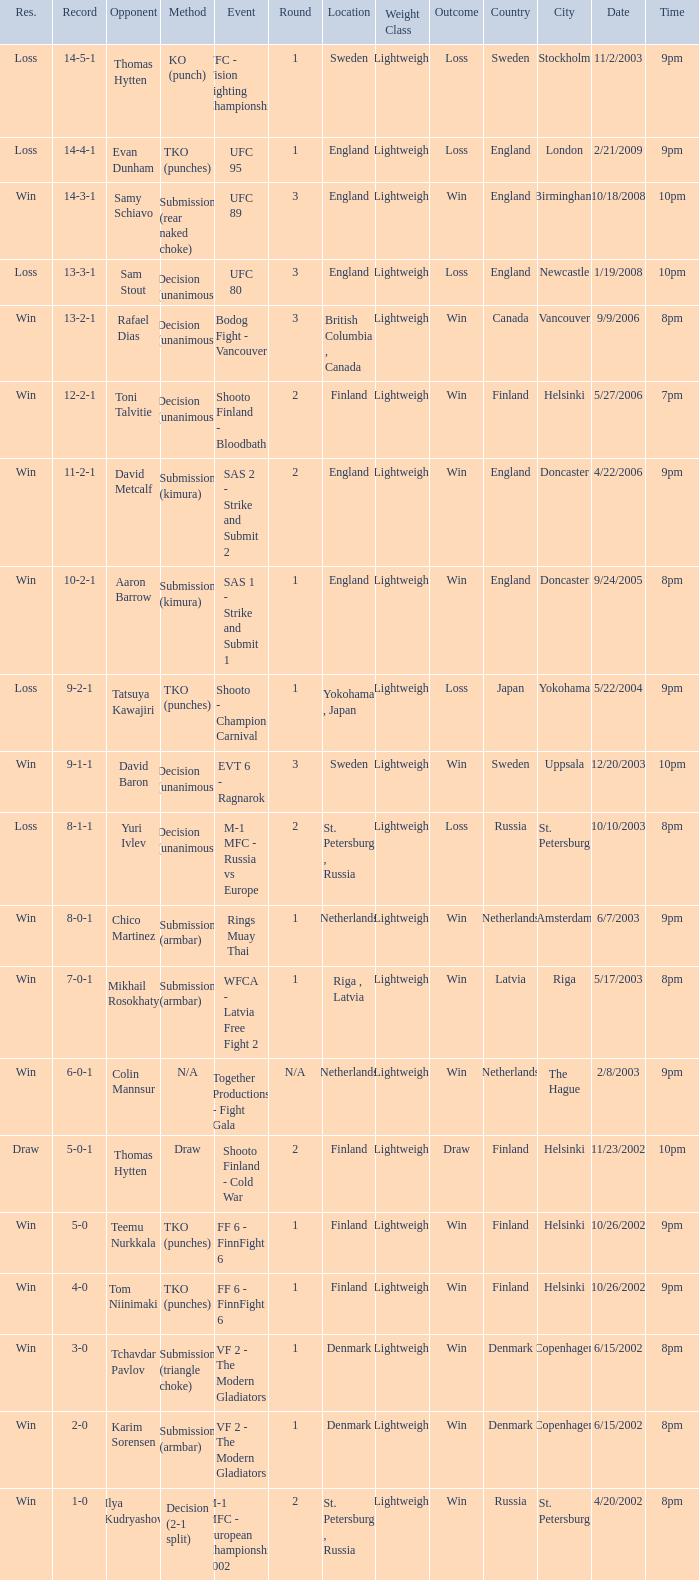I'm looking to parse the entire table for insights. Could you assist me with that? {'header': ['Res.', 'Record', 'Opponent', 'Method', 'Event', 'Round', 'Location', 'Weight Class', 'Outcome', 'Country', 'City', 'Date', 'Time'], 'rows': [['Loss', '14-5-1', 'Thomas Hytten', 'KO (punch)', 'VFC - Vision Fighting Championship 2', '1', 'Sweden', 'Lightweight', 'Loss', 'Sweden', 'Stockholm', '11/2/2003', '9pm'], ['Loss', '14-4-1', 'Evan Dunham', 'TKO (punches)', 'UFC 95', '1', 'England', 'Lightweight', 'Loss', 'England', 'London', '2/21/2009', '9pm'], ['Win', '14-3-1', 'Samy Schiavo', 'Submission (rear naked choke)', 'UFC 89', '3', 'England', 'Lightweight', 'Win', 'England', 'Birmingham', '10/18/2008', '10pm'], ['Loss', '13-3-1', 'Sam Stout', 'Decision (unanimous)', 'UFC 80', '3', 'England', 'Lightweight', 'Loss', 'England', 'Newcastle', '1/19/2008', '10pm'], ['Win', '13-2-1', 'Rafael Dias', 'Decision (unanimous)', 'Bodog Fight - Vancouver', '3', 'British Columbia , Canada', 'Lightweight', 'Win', 'Canada', 'Vancouver', '9/9/2006', '8pm'], ['Win', '12-2-1', 'Toni Talvitie', 'Decision (unanimous)', 'Shooto Finland - Bloodbath', '2', 'Finland', 'Lightweight', 'Win', 'Finland', 'Helsinki', '5/27/2006', '7pm'], ['Win', '11-2-1', 'David Metcalf', 'Submission (kimura)', 'SAS 2 - Strike and Submit 2', '2', 'England', 'Lightweight', 'Win', 'England', 'Doncaster', '4/22/2006', '9pm'], ['Win', '10-2-1', 'Aaron Barrow', 'Submission (kimura)', 'SAS 1 - Strike and Submit 1', '1', 'England', 'Lightweight', 'Win', 'England', 'Doncaster', '9/24/2005', '8pm'], ['Loss', '9-2-1', 'Tatsuya Kawajiri', 'TKO (punches)', 'Shooto - Champion Carnival', '1', 'Yokohama , Japan', 'Lightweight', 'Loss', 'Japan', 'Yokohama', '5/22/2004', '9pm'], ['Win', '9-1-1', 'David Baron', 'Decision (unanimous)', 'EVT 6 - Ragnarok', '3', 'Sweden', 'Lightweight', 'Win', 'Sweden', 'Uppsala', '12/20/2003', '10pm'], ['Loss', '8-1-1', 'Yuri Ivlev', 'Decision (unanimous)', 'M-1 MFC - Russia vs Europe', '2', 'St. Petersburg , Russia', 'Lightweight', 'Loss', 'Russia', 'St. Petersburg', '10/10/2003', '8pm'], ['Win', '8-0-1', 'Chico Martinez', 'Submission (armbar)', 'Rings Muay Thai', '1', 'Netherlands', 'Lightweight', 'Win', 'Netherlands', 'Amsterdam', '6/7/2003', '9pm'], ['Win', '7-0-1', 'Mikhail Rosokhaty', 'Submission (armbar)', 'WFCA - Latvia Free Fight 2', '1', 'Riga , Latvia', 'Lightweight', 'Win', 'Latvia', 'Riga', '5/17/2003', '8pm'], ['Win', '6-0-1', 'Colin Mannsur', 'N/A', 'Together Productions - Fight Gala', 'N/A', 'Netherlands', 'Lightweight', 'Win', 'Netherlands', 'The Hague', '2/8/2003', '9pm'], ['Draw', '5-0-1', 'Thomas Hytten', 'Draw', 'Shooto Finland - Cold War', '2', 'Finland', 'Lightweight', 'Draw', 'Finland', 'Helsinki', '11/23/2002', '10pm'], ['Win', '5-0', 'Teemu Nurkkala', 'TKO (punches)', 'FF 6 - FinnFight 6', '1', 'Finland', 'Lightweight', 'Win', 'Finland', 'Helsinki', '10/26/2002', '9pm'], ['Win', '4-0', 'Tom Niinimaki', 'TKO (punches)', 'FF 6 - FinnFight 6', '1', 'Finland', 'Lightweight', 'Win', 'Finland', 'Helsinki', '10/26/2002', '9pm'], ['Win', '3-0', 'Tchavdar Pavlov', 'Submission (triangle choke)', 'VF 2 - The Modern Gladiators', '1', 'Denmark', 'Lightweight', 'Win', 'Denmark', 'Copenhagen', '6/15/2002', '8pm'], ['Win', '2-0', 'Karim Sorensen', 'Submission (armbar)', 'VF 2 - The Modern Gladiators', '1', 'Denmark', 'Lightweight', 'Win', 'Denmark', 'Copenhagen', '6/15/2002', '8pm'], ['Win', '1-0', 'Ilya Kudryashov', 'Decision (2-1 split)', 'M-1 MFC - European Championship 2002', '2', 'St. Petersburg , Russia', 'Lightweight', 'Win', 'Russia', 'St. Petersburg', '4/20/2002', '8pm']]} What is the round in Finland with a draw for method? 2.0. 